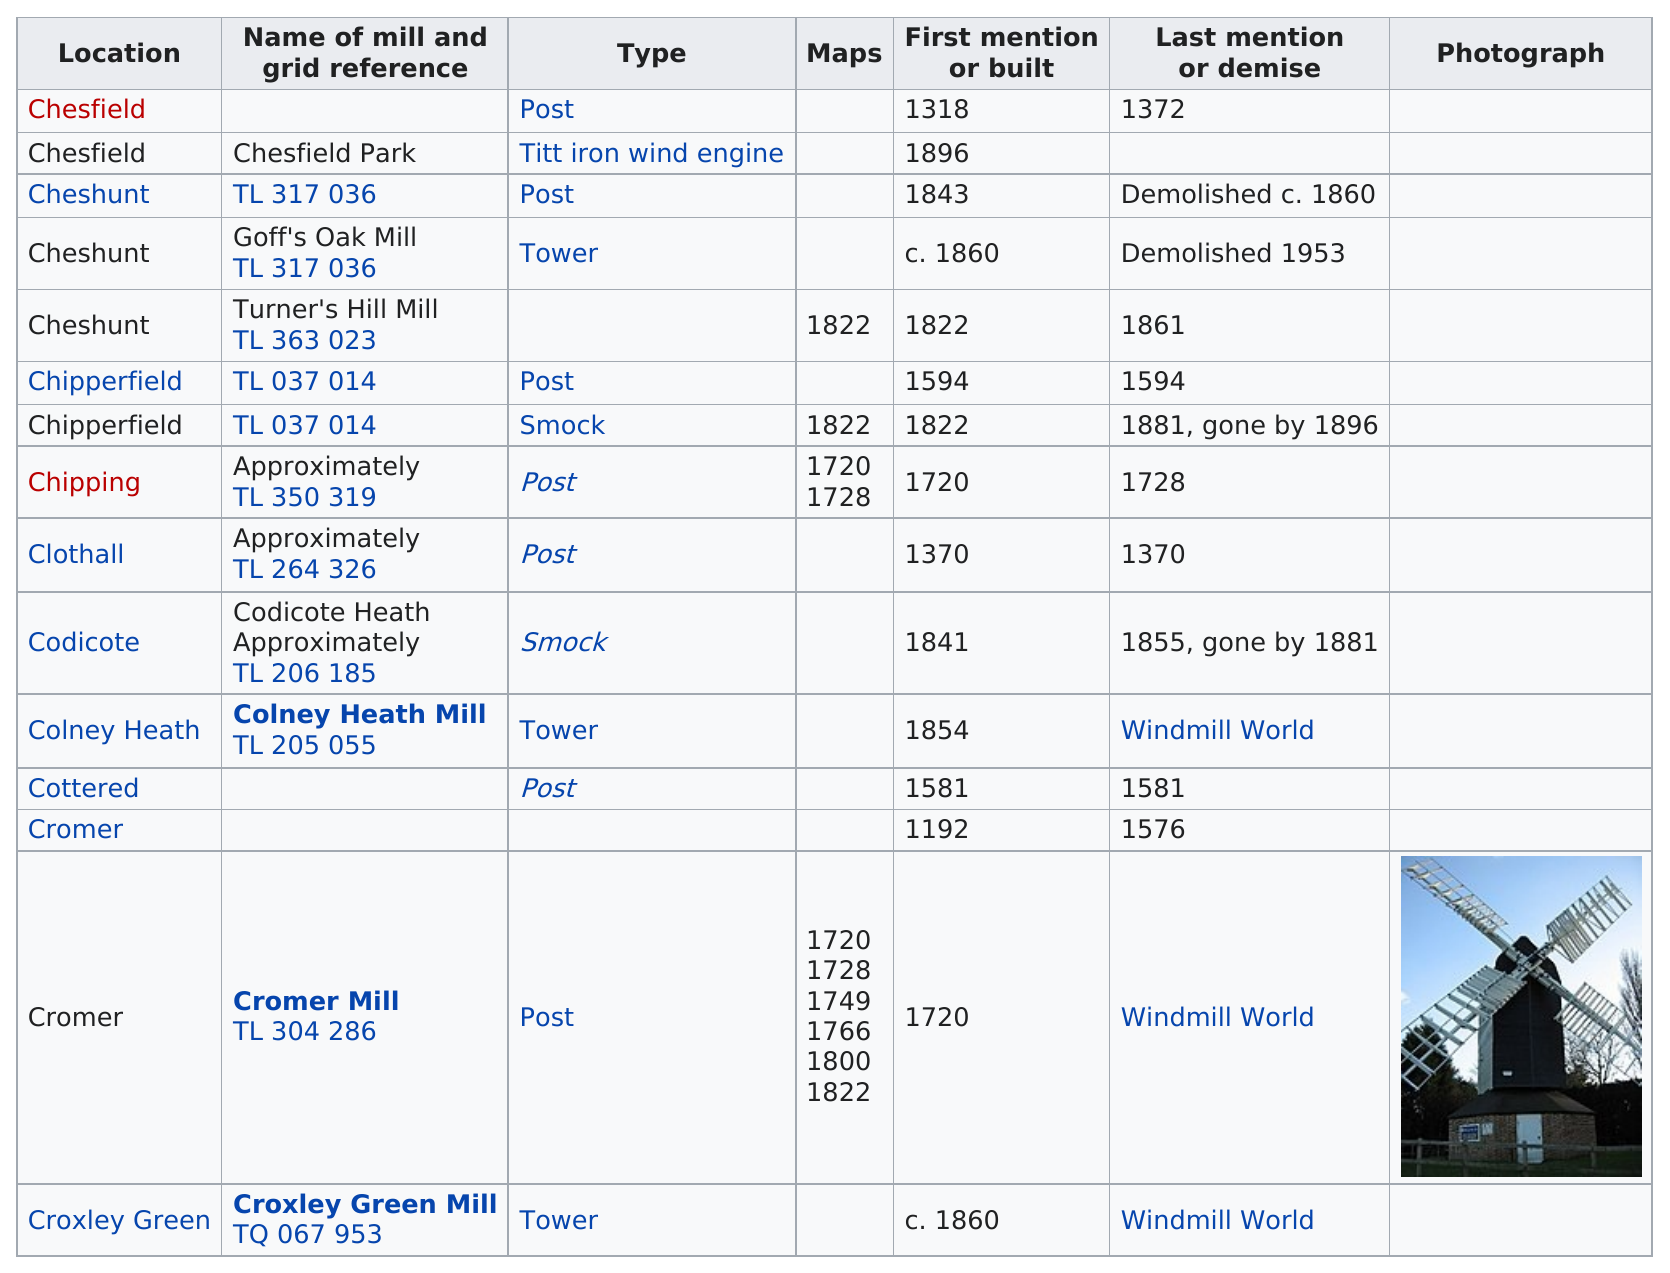Indicate a few pertinent items in this graphic. Colney Heath Mill is the only "c" mill located in Colney Health. The total number of mills named Cheshunt is 3. Following the act of chipping, the next location is Clothall. There are 14 locations that do not have photographs available. The number of mills first mentioned or built in the 1800s was 8. 